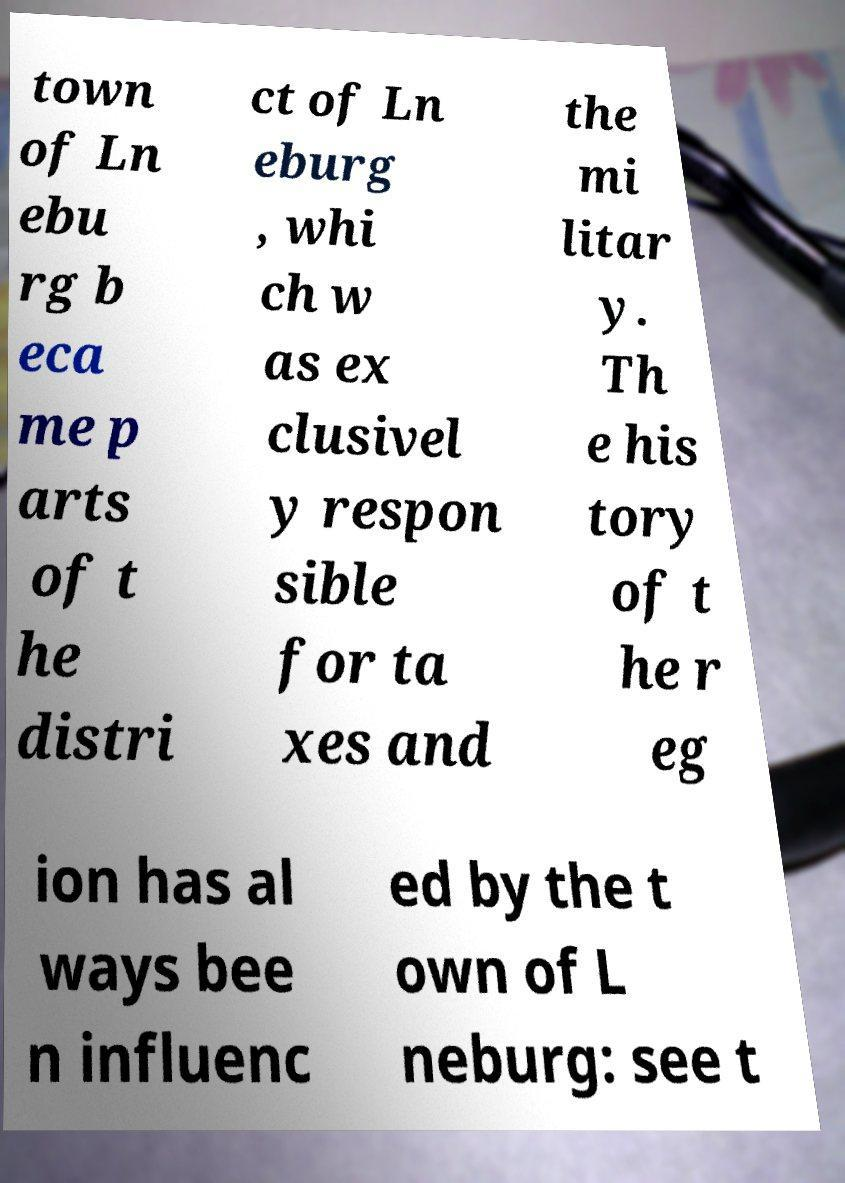Please read and relay the text visible in this image. What does it say? town of Ln ebu rg b eca me p arts of t he distri ct of Ln eburg , whi ch w as ex clusivel y respon sible for ta xes and the mi litar y. Th e his tory of t he r eg ion has al ways bee n influenc ed by the t own of L neburg: see t 